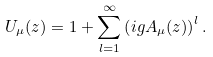Convert formula to latex. <formula><loc_0><loc_0><loc_500><loc_500>U _ { \mu } ( z ) = 1 + \sum _ { l = 1 } ^ { \infty } \left ( i g A _ { \mu } ( z ) \right ) ^ { l } .</formula> 